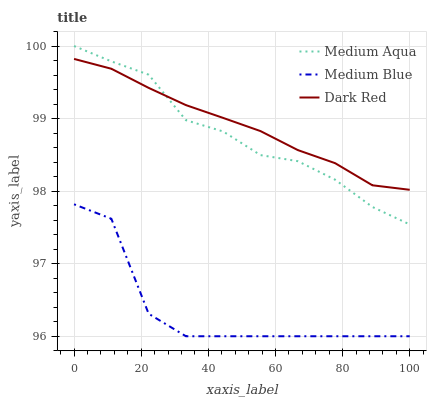Does Medium Blue have the minimum area under the curve?
Answer yes or no. Yes. Does Dark Red have the maximum area under the curve?
Answer yes or no. Yes. Does Medium Aqua have the minimum area under the curve?
Answer yes or no. No. Does Medium Aqua have the maximum area under the curve?
Answer yes or no. No. Is Dark Red the smoothest?
Answer yes or no. Yes. Is Medium Blue the roughest?
Answer yes or no. Yes. Is Medium Aqua the smoothest?
Answer yes or no. No. Is Medium Aqua the roughest?
Answer yes or no. No. Does Medium Blue have the lowest value?
Answer yes or no. Yes. Does Medium Aqua have the lowest value?
Answer yes or no. No. Does Medium Aqua have the highest value?
Answer yes or no. Yes. Does Dark Red have the highest value?
Answer yes or no. No. Is Medium Blue less than Medium Aqua?
Answer yes or no. Yes. Is Dark Red greater than Medium Blue?
Answer yes or no. Yes. Does Medium Aqua intersect Dark Red?
Answer yes or no. Yes. Is Medium Aqua less than Dark Red?
Answer yes or no. No. Is Medium Aqua greater than Dark Red?
Answer yes or no. No. Does Medium Blue intersect Medium Aqua?
Answer yes or no. No. 